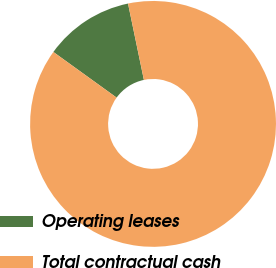Convert chart. <chart><loc_0><loc_0><loc_500><loc_500><pie_chart><fcel>Operating leases<fcel>Total contractual cash<nl><fcel>11.79%<fcel>88.21%<nl></chart> 